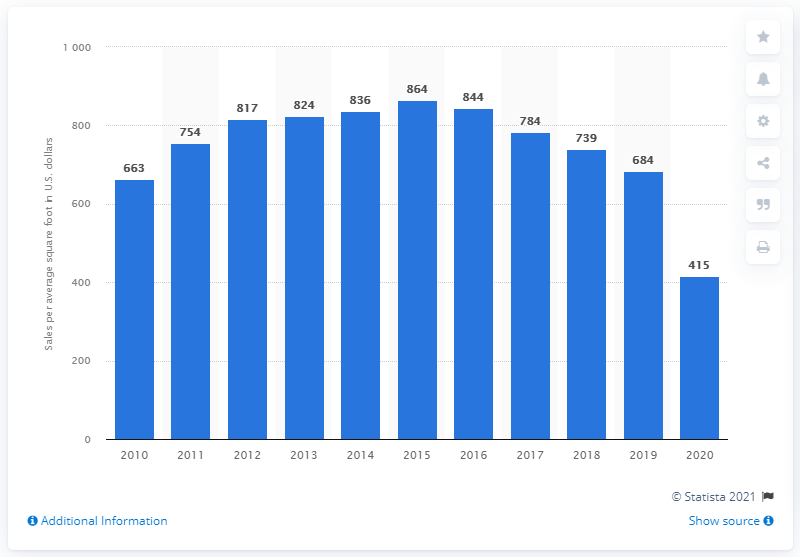Draw attention to some important aspects in this diagram. In 2020, the sales per average selling square foot of Victoria's Secret was approximately 415. 